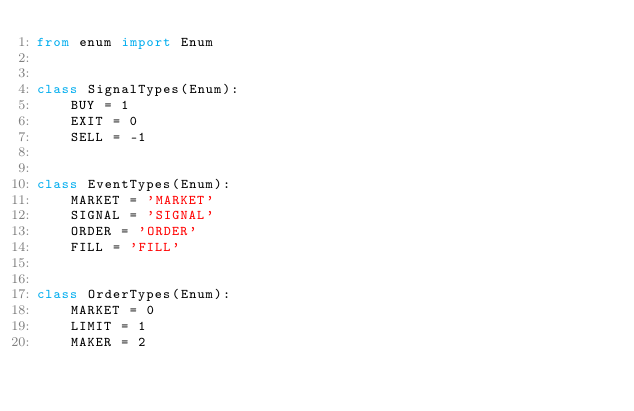<code> <loc_0><loc_0><loc_500><loc_500><_Python_>from enum import Enum


class SignalTypes(Enum):
    BUY = 1
    EXIT = 0
    SELL = -1


class EventTypes(Enum):
    MARKET = 'MARKET'
    SIGNAL = 'SIGNAL'
    ORDER = 'ORDER'
    FILL = 'FILL'


class OrderTypes(Enum):
    MARKET = 0
    LIMIT = 1
    MAKER = 2
</code> 